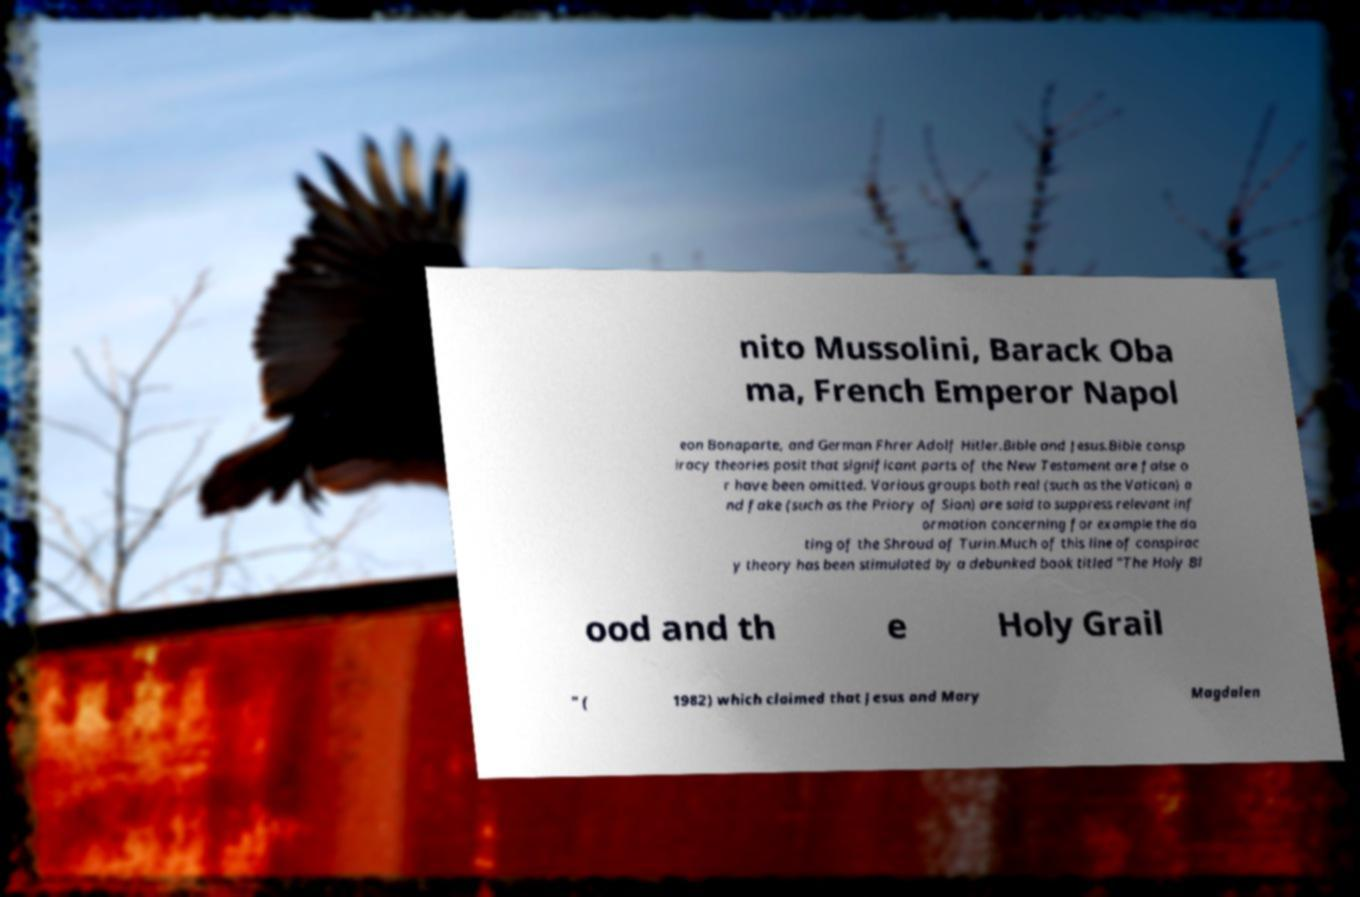Please read and relay the text visible in this image. What does it say? nito Mussolini, Barack Oba ma, French Emperor Napol eon Bonaparte, and German Fhrer Adolf Hitler.Bible and Jesus.Bible consp iracy theories posit that significant parts of the New Testament are false o r have been omitted. Various groups both real (such as the Vatican) a nd fake (such as the Priory of Sion) are said to suppress relevant inf ormation concerning for example the da ting of the Shroud of Turin.Much of this line of conspirac y theory has been stimulated by a debunked book titled "The Holy Bl ood and th e Holy Grail " ( 1982) which claimed that Jesus and Mary Magdalen 